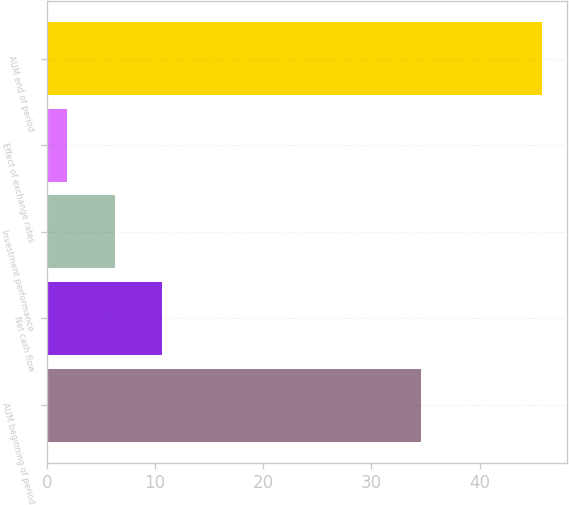Convert chart. <chart><loc_0><loc_0><loc_500><loc_500><bar_chart><fcel>AUM beginning of period<fcel>Net cash flow<fcel>Investment performance<fcel>Effect of exchange rates<fcel>AUM end of period<nl><fcel>34.6<fcel>10.68<fcel>6.29<fcel>1.9<fcel>45.8<nl></chart> 